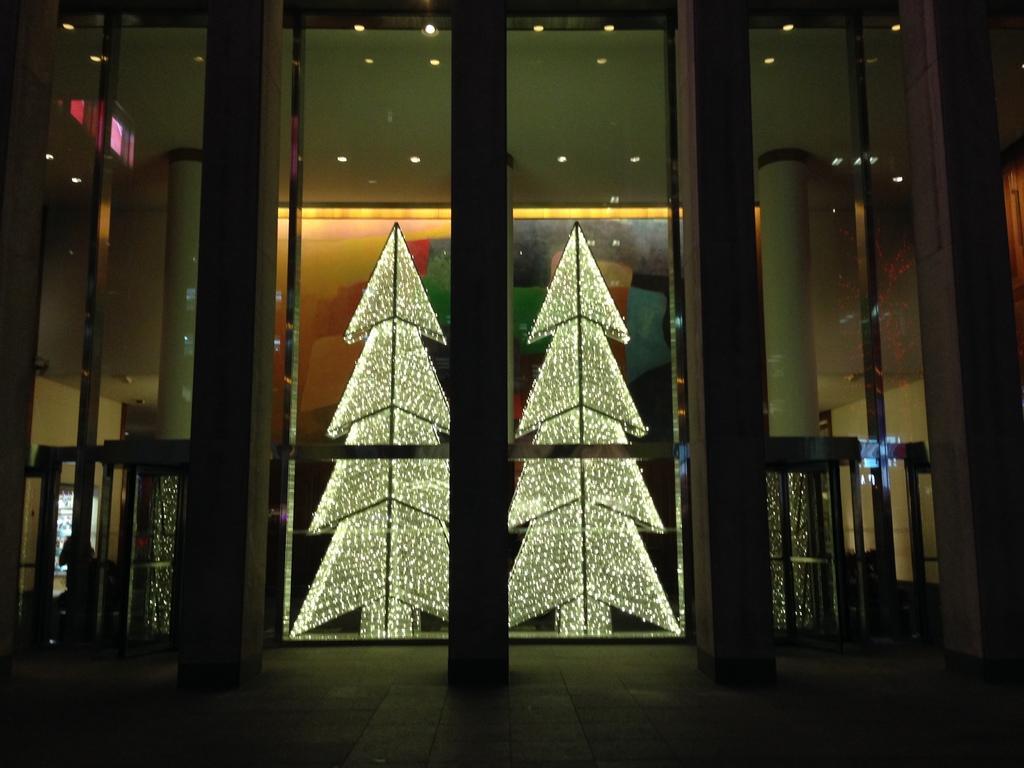Please provide a concise description of this image. The picture consists of a building. In the foreground there is a glass court, inside the door, there are lights, pillars. On the left, in the background there is a person. 